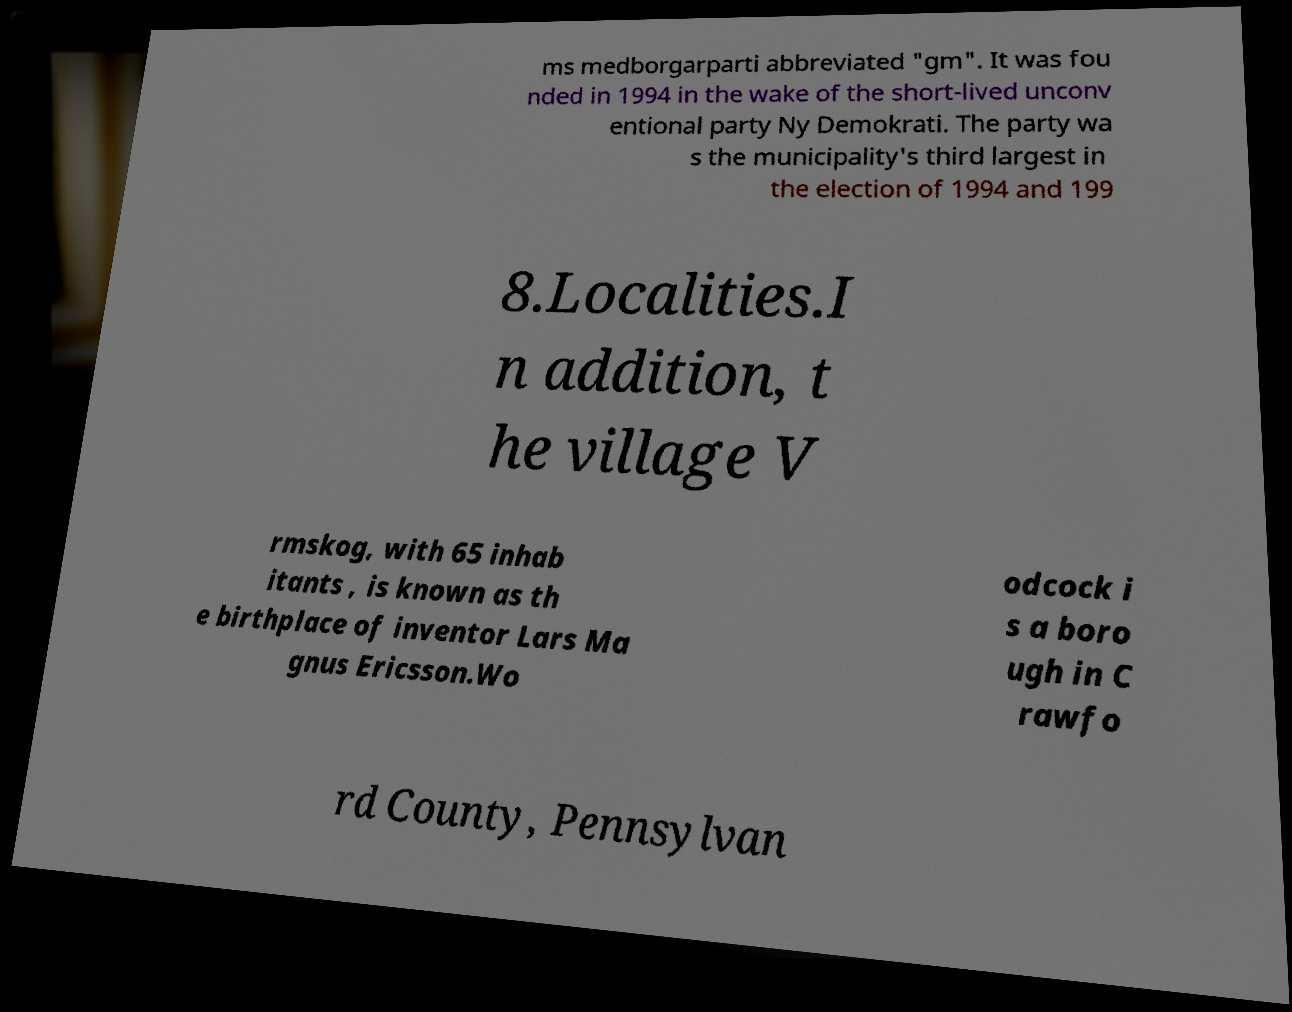I need the written content from this picture converted into text. Can you do that? ms medborgarparti abbreviated "gm". It was fou nded in 1994 in the wake of the short-lived unconv entional party Ny Demokrati. The party wa s the municipality's third largest in the election of 1994 and 199 8.Localities.I n addition, t he village V rmskog, with 65 inhab itants , is known as th e birthplace of inventor Lars Ma gnus Ericsson.Wo odcock i s a boro ugh in C rawfo rd County, Pennsylvan 